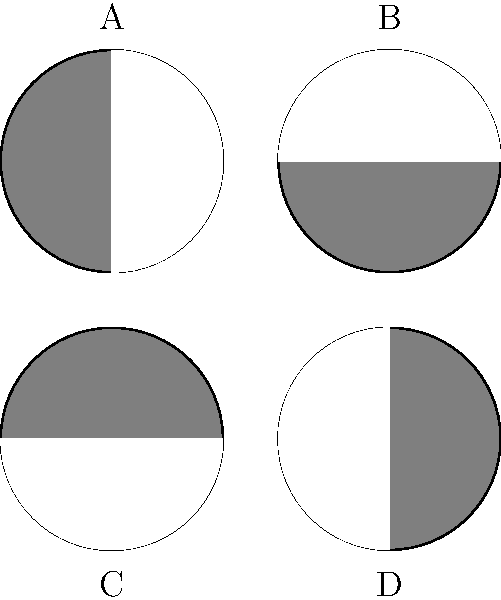Dear, which of the moon phases shown above represents the First Quarter Moon? Let's go through this step-by-step, my dear:

1. First, let's recall what a First Quarter Moon looks like. It occurs when we see half of the Moon's illuminated surface from Earth.

2. In a First Quarter Moon, the right half of the Moon appears lit while the left half is dark.

3. Now, let's look at each of the moon phases in the diagram:

   A: This shows a half-moon with the left side illuminated.
   B: This shows a half-moon with the right side illuminated.
   C: This is similar to B, but upside down.
   D: This is similar to A, but upside down.

4. The First Quarter Moon is represented by the phase where the right half is illuminated and the left half is dark when viewed from the Northern Hemisphere.

5. Looking at our options, we can see that diagram B matches this description perfectly.

Therefore, the moon phase labeled B represents the First Quarter Moon.
Answer: B 